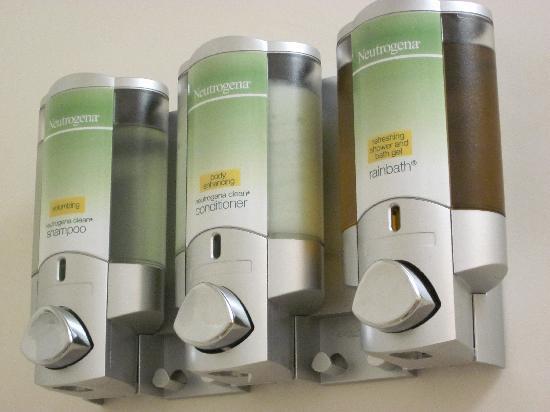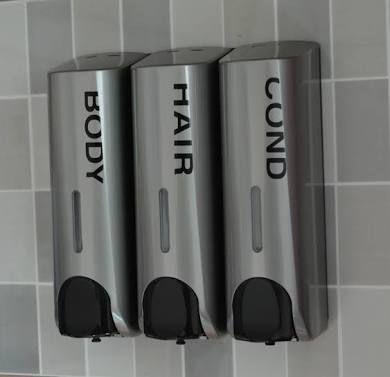The first image is the image on the left, the second image is the image on the right. Evaluate the accuracy of this statement regarding the images: "Each image contains at least three dispensers in a line.". Is it true? Answer yes or no. Yes. The first image is the image on the left, the second image is the image on the right. Given the left and right images, does the statement "At least one image shows a chrome rack with a suspended round scrubber, between two dispensers." hold true? Answer yes or no. No. 